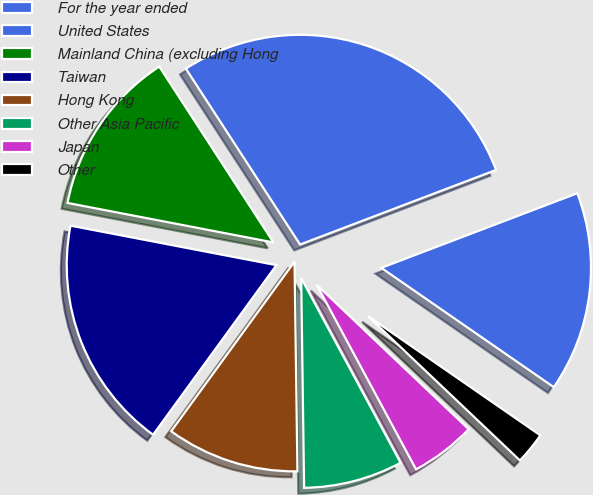Convert chart to OTSL. <chart><loc_0><loc_0><loc_500><loc_500><pie_chart><fcel>For the year ended<fcel>United States<fcel>Mainland China (excluding Hong<fcel>Taiwan<fcel>Hong Kong<fcel>Other Asia Pacific<fcel>Japan<fcel>Other<nl><fcel>15.42%<fcel>28.38%<fcel>12.82%<fcel>18.01%<fcel>10.23%<fcel>7.64%<fcel>5.05%<fcel>2.46%<nl></chart> 